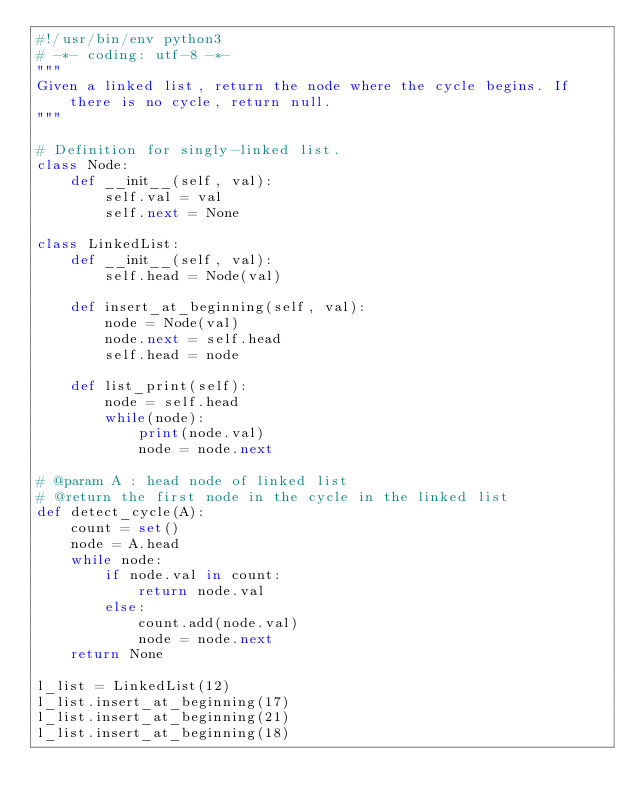Convert code to text. <code><loc_0><loc_0><loc_500><loc_500><_Python_>#!/usr/bin/env python3
# -*- coding: utf-8 -*-
"""
Given a linked list, return the node where the cycle begins. If there is no cycle, return null.
"""

# Definition for singly-linked list.
class Node:
    def __init__(self, val):
        self.val = val
        self.next = None

class LinkedList:
    def __init__(self, val):
        self.head = Node(val)

    def insert_at_beginning(self, val):
        node = Node(val)
        node.next = self.head
        self.head = node
       
    def list_print(self):
        node = self.head
        while(node):
            print(node.val)
            node = node.next

# @param A : head node of linked list
# @return the first node in the cycle in the linked list
def detect_cycle(A):
    count = set()
    node = A.head
    while node:
        if node.val in count:
            return node.val
        else:
            count.add(node.val)
            node = node.next
    return None

l_list = LinkedList(12)
l_list.insert_at_beginning(17)
l_list.insert_at_beginning(21)
l_list.insert_at_beginning(18)</code> 